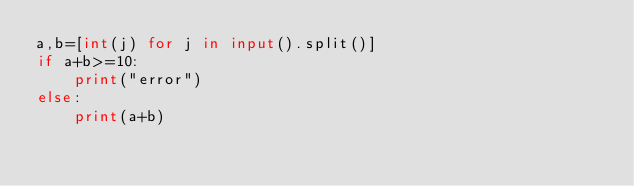Convert code to text. <code><loc_0><loc_0><loc_500><loc_500><_Python_>a,b=[int(j) for j in input().split()]
if a+b>=10:
    print("error")
else:
    print(a+b)


</code> 